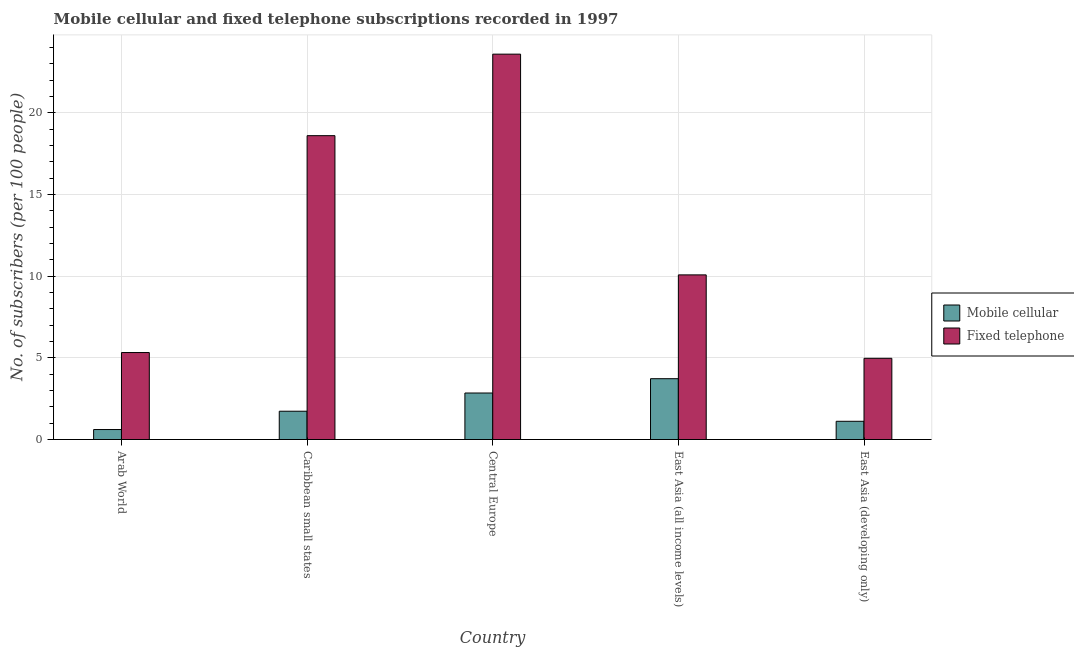How many different coloured bars are there?
Offer a terse response. 2. Are the number of bars per tick equal to the number of legend labels?
Offer a very short reply. Yes. Are the number of bars on each tick of the X-axis equal?
Offer a terse response. Yes. How many bars are there on the 4th tick from the left?
Keep it short and to the point. 2. How many bars are there on the 1st tick from the right?
Your response must be concise. 2. What is the label of the 5th group of bars from the left?
Your response must be concise. East Asia (developing only). What is the number of fixed telephone subscribers in Caribbean small states?
Give a very brief answer. 18.61. Across all countries, what is the maximum number of fixed telephone subscribers?
Ensure brevity in your answer.  23.6. Across all countries, what is the minimum number of mobile cellular subscribers?
Give a very brief answer. 0.61. In which country was the number of fixed telephone subscribers maximum?
Your answer should be very brief. Central Europe. In which country was the number of mobile cellular subscribers minimum?
Give a very brief answer. Arab World. What is the total number of mobile cellular subscribers in the graph?
Offer a terse response. 10.03. What is the difference between the number of fixed telephone subscribers in Arab World and that in Central Europe?
Provide a short and direct response. -18.28. What is the difference between the number of mobile cellular subscribers in East Asia (developing only) and the number of fixed telephone subscribers in Caribbean small states?
Keep it short and to the point. -17.49. What is the average number of mobile cellular subscribers per country?
Your response must be concise. 2.01. What is the difference between the number of fixed telephone subscribers and number of mobile cellular subscribers in Caribbean small states?
Offer a terse response. 16.88. In how many countries, is the number of mobile cellular subscribers greater than 17 ?
Your response must be concise. 0. What is the ratio of the number of mobile cellular subscribers in East Asia (all income levels) to that in East Asia (developing only)?
Offer a very short reply. 3.34. Is the number of mobile cellular subscribers in Arab World less than that in East Asia (developing only)?
Your answer should be compact. Yes. What is the difference between the highest and the second highest number of mobile cellular subscribers?
Make the answer very short. 0.88. What is the difference between the highest and the lowest number of mobile cellular subscribers?
Ensure brevity in your answer.  3.11. In how many countries, is the number of mobile cellular subscribers greater than the average number of mobile cellular subscribers taken over all countries?
Your answer should be very brief. 2. What does the 2nd bar from the left in Caribbean small states represents?
Ensure brevity in your answer.  Fixed telephone. What does the 1st bar from the right in Arab World represents?
Ensure brevity in your answer.  Fixed telephone. Does the graph contain any zero values?
Keep it short and to the point. No. Does the graph contain grids?
Provide a succinct answer. Yes. How many legend labels are there?
Offer a terse response. 2. How are the legend labels stacked?
Your answer should be very brief. Vertical. What is the title of the graph?
Your answer should be compact. Mobile cellular and fixed telephone subscriptions recorded in 1997. What is the label or title of the X-axis?
Ensure brevity in your answer.  Country. What is the label or title of the Y-axis?
Your answer should be very brief. No. of subscribers (per 100 people). What is the No. of subscribers (per 100 people) in Mobile cellular in Arab World?
Ensure brevity in your answer.  0.61. What is the No. of subscribers (per 100 people) in Fixed telephone in Arab World?
Make the answer very short. 5.33. What is the No. of subscribers (per 100 people) of Mobile cellular in Caribbean small states?
Make the answer very short. 1.73. What is the No. of subscribers (per 100 people) of Fixed telephone in Caribbean small states?
Ensure brevity in your answer.  18.61. What is the No. of subscribers (per 100 people) in Mobile cellular in Central Europe?
Keep it short and to the point. 2.85. What is the No. of subscribers (per 100 people) of Fixed telephone in Central Europe?
Give a very brief answer. 23.6. What is the No. of subscribers (per 100 people) of Mobile cellular in East Asia (all income levels)?
Provide a short and direct response. 3.73. What is the No. of subscribers (per 100 people) in Fixed telephone in East Asia (all income levels)?
Give a very brief answer. 10.08. What is the No. of subscribers (per 100 people) of Mobile cellular in East Asia (developing only)?
Provide a short and direct response. 1.12. What is the No. of subscribers (per 100 people) of Fixed telephone in East Asia (developing only)?
Keep it short and to the point. 4.97. Across all countries, what is the maximum No. of subscribers (per 100 people) in Mobile cellular?
Provide a succinct answer. 3.73. Across all countries, what is the maximum No. of subscribers (per 100 people) of Fixed telephone?
Offer a very short reply. 23.6. Across all countries, what is the minimum No. of subscribers (per 100 people) in Mobile cellular?
Give a very brief answer. 0.61. Across all countries, what is the minimum No. of subscribers (per 100 people) in Fixed telephone?
Provide a short and direct response. 4.97. What is the total No. of subscribers (per 100 people) in Mobile cellular in the graph?
Ensure brevity in your answer.  10.03. What is the total No. of subscribers (per 100 people) in Fixed telephone in the graph?
Give a very brief answer. 62.6. What is the difference between the No. of subscribers (per 100 people) in Mobile cellular in Arab World and that in Caribbean small states?
Your answer should be very brief. -1.12. What is the difference between the No. of subscribers (per 100 people) in Fixed telephone in Arab World and that in Caribbean small states?
Provide a succinct answer. -13.28. What is the difference between the No. of subscribers (per 100 people) in Mobile cellular in Arab World and that in Central Europe?
Your response must be concise. -2.24. What is the difference between the No. of subscribers (per 100 people) in Fixed telephone in Arab World and that in Central Europe?
Offer a terse response. -18.28. What is the difference between the No. of subscribers (per 100 people) in Mobile cellular in Arab World and that in East Asia (all income levels)?
Your response must be concise. -3.11. What is the difference between the No. of subscribers (per 100 people) in Fixed telephone in Arab World and that in East Asia (all income levels)?
Give a very brief answer. -4.76. What is the difference between the No. of subscribers (per 100 people) in Mobile cellular in Arab World and that in East Asia (developing only)?
Ensure brevity in your answer.  -0.5. What is the difference between the No. of subscribers (per 100 people) in Fixed telephone in Arab World and that in East Asia (developing only)?
Offer a terse response. 0.35. What is the difference between the No. of subscribers (per 100 people) in Mobile cellular in Caribbean small states and that in Central Europe?
Your answer should be very brief. -1.12. What is the difference between the No. of subscribers (per 100 people) in Fixed telephone in Caribbean small states and that in Central Europe?
Ensure brevity in your answer.  -4.99. What is the difference between the No. of subscribers (per 100 people) of Mobile cellular in Caribbean small states and that in East Asia (all income levels)?
Give a very brief answer. -1.99. What is the difference between the No. of subscribers (per 100 people) of Fixed telephone in Caribbean small states and that in East Asia (all income levels)?
Keep it short and to the point. 8.53. What is the difference between the No. of subscribers (per 100 people) in Mobile cellular in Caribbean small states and that in East Asia (developing only)?
Your answer should be compact. 0.62. What is the difference between the No. of subscribers (per 100 people) in Fixed telephone in Caribbean small states and that in East Asia (developing only)?
Offer a terse response. 13.64. What is the difference between the No. of subscribers (per 100 people) in Mobile cellular in Central Europe and that in East Asia (all income levels)?
Offer a terse response. -0.88. What is the difference between the No. of subscribers (per 100 people) of Fixed telephone in Central Europe and that in East Asia (all income levels)?
Your answer should be very brief. 13.52. What is the difference between the No. of subscribers (per 100 people) of Mobile cellular in Central Europe and that in East Asia (developing only)?
Offer a terse response. 1.73. What is the difference between the No. of subscribers (per 100 people) of Fixed telephone in Central Europe and that in East Asia (developing only)?
Ensure brevity in your answer.  18.63. What is the difference between the No. of subscribers (per 100 people) in Mobile cellular in East Asia (all income levels) and that in East Asia (developing only)?
Give a very brief answer. 2.61. What is the difference between the No. of subscribers (per 100 people) in Fixed telephone in East Asia (all income levels) and that in East Asia (developing only)?
Make the answer very short. 5.11. What is the difference between the No. of subscribers (per 100 people) in Mobile cellular in Arab World and the No. of subscribers (per 100 people) in Fixed telephone in Caribbean small states?
Provide a succinct answer. -18. What is the difference between the No. of subscribers (per 100 people) of Mobile cellular in Arab World and the No. of subscribers (per 100 people) of Fixed telephone in Central Europe?
Ensure brevity in your answer.  -22.99. What is the difference between the No. of subscribers (per 100 people) in Mobile cellular in Arab World and the No. of subscribers (per 100 people) in Fixed telephone in East Asia (all income levels)?
Your answer should be very brief. -9.47. What is the difference between the No. of subscribers (per 100 people) in Mobile cellular in Arab World and the No. of subscribers (per 100 people) in Fixed telephone in East Asia (developing only)?
Keep it short and to the point. -4.36. What is the difference between the No. of subscribers (per 100 people) in Mobile cellular in Caribbean small states and the No. of subscribers (per 100 people) in Fixed telephone in Central Europe?
Offer a very short reply. -21.87. What is the difference between the No. of subscribers (per 100 people) of Mobile cellular in Caribbean small states and the No. of subscribers (per 100 people) of Fixed telephone in East Asia (all income levels)?
Your response must be concise. -8.35. What is the difference between the No. of subscribers (per 100 people) in Mobile cellular in Caribbean small states and the No. of subscribers (per 100 people) in Fixed telephone in East Asia (developing only)?
Make the answer very short. -3.24. What is the difference between the No. of subscribers (per 100 people) in Mobile cellular in Central Europe and the No. of subscribers (per 100 people) in Fixed telephone in East Asia (all income levels)?
Ensure brevity in your answer.  -7.23. What is the difference between the No. of subscribers (per 100 people) of Mobile cellular in Central Europe and the No. of subscribers (per 100 people) of Fixed telephone in East Asia (developing only)?
Ensure brevity in your answer.  -2.13. What is the difference between the No. of subscribers (per 100 people) in Mobile cellular in East Asia (all income levels) and the No. of subscribers (per 100 people) in Fixed telephone in East Asia (developing only)?
Offer a terse response. -1.25. What is the average No. of subscribers (per 100 people) of Mobile cellular per country?
Your answer should be compact. 2.01. What is the average No. of subscribers (per 100 people) of Fixed telephone per country?
Offer a terse response. 12.52. What is the difference between the No. of subscribers (per 100 people) in Mobile cellular and No. of subscribers (per 100 people) in Fixed telephone in Arab World?
Give a very brief answer. -4.72. What is the difference between the No. of subscribers (per 100 people) in Mobile cellular and No. of subscribers (per 100 people) in Fixed telephone in Caribbean small states?
Your answer should be compact. -16.88. What is the difference between the No. of subscribers (per 100 people) of Mobile cellular and No. of subscribers (per 100 people) of Fixed telephone in Central Europe?
Offer a terse response. -20.75. What is the difference between the No. of subscribers (per 100 people) of Mobile cellular and No. of subscribers (per 100 people) of Fixed telephone in East Asia (all income levels)?
Your response must be concise. -6.36. What is the difference between the No. of subscribers (per 100 people) in Mobile cellular and No. of subscribers (per 100 people) in Fixed telephone in East Asia (developing only)?
Provide a short and direct response. -3.86. What is the ratio of the No. of subscribers (per 100 people) of Mobile cellular in Arab World to that in Caribbean small states?
Your answer should be very brief. 0.35. What is the ratio of the No. of subscribers (per 100 people) of Fixed telephone in Arab World to that in Caribbean small states?
Provide a short and direct response. 0.29. What is the ratio of the No. of subscribers (per 100 people) of Mobile cellular in Arab World to that in Central Europe?
Your answer should be compact. 0.21. What is the ratio of the No. of subscribers (per 100 people) of Fixed telephone in Arab World to that in Central Europe?
Give a very brief answer. 0.23. What is the ratio of the No. of subscribers (per 100 people) of Mobile cellular in Arab World to that in East Asia (all income levels)?
Offer a terse response. 0.16. What is the ratio of the No. of subscribers (per 100 people) of Fixed telephone in Arab World to that in East Asia (all income levels)?
Give a very brief answer. 0.53. What is the ratio of the No. of subscribers (per 100 people) of Mobile cellular in Arab World to that in East Asia (developing only)?
Provide a succinct answer. 0.55. What is the ratio of the No. of subscribers (per 100 people) of Fixed telephone in Arab World to that in East Asia (developing only)?
Keep it short and to the point. 1.07. What is the ratio of the No. of subscribers (per 100 people) of Mobile cellular in Caribbean small states to that in Central Europe?
Give a very brief answer. 0.61. What is the ratio of the No. of subscribers (per 100 people) in Fixed telephone in Caribbean small states to that in Central Europe?
Ensure brevity in your answer.  0.79. What is the ratio of the No. of subscribers (per 100 people) in Mobile cellular in Caribbean small states to that in East Asia (all income levels)?
Provide a short and direct response. 0.47. What is the ratio of the No. of subscribers (per 100 people) of Fixed telephone in Caribbean small states to that in East Asia (all income levels)?
Give a very brief answer. 1.85. What is the ratio of the No. of subscribers (per 100 people) of Mobile cellular in Caribbean small states to that in East Asia (developing only)?
Provide a short and direct response. 1.55. What is the ratio of the No. of subscribers (per 100 people) of Fixed telephone in Caribbean small states to that in East Asia (developing only)?
Your response must be concise. 3.74. What is the ratio of the No. of subscribers (per 100 people) of Mobile cellular in Central Europe to that in East Asia (all income levels)?
Provide a short and direct response. 0.76. What is the ratio of the No. of subscribers (per 100 people) of Fixed telephone in Central Europe to that in East Asia (all income levels)?
Provide a short and direct response. 2.34. What is the ratio of the No. of subscribers (per 100 people) in Mobile cellular in Central Europe to that in East Asia (developing only)?
Offer a terse response. 2.55. What is the ratio of the No. of subscribers (per 100 people) in Fixed telephone in Central Europe to that in East Asia (developing only)?
Provide a short and direct response. 4.74. What is the ratio of the No. of subscribers (per 100 people) of Mobile cellular in East Asia (all income levels) to that in East Asia (developing only)?
Provide a short and direct response. 3.34. What is the ratio of the No. of subscribers (per 100 people) of Fixed telephone in East Asia (all income levels) to that in East Asia (developing only)?
Provide a succinct answer. 2.03. What is the difference between the highest and the second highest No. of subscribers (per 100 people) in Mobile cellular?
Provide a short and direct response. 0.88. What is the difference between the highest and the second highest No. of subscribers (per 100 people) in Fixed telephone?
Offer a very short reply. 4.99. What is the difference between the highest and the lowest No. of subscribers (per 100 people) of Mobile cellular?
Your response must be concise. 3.11. What is the difference between the highest and the lowest No. of subscribers (per 100 people) in Fixed telephone?
Make the answer very short. 18.63. 